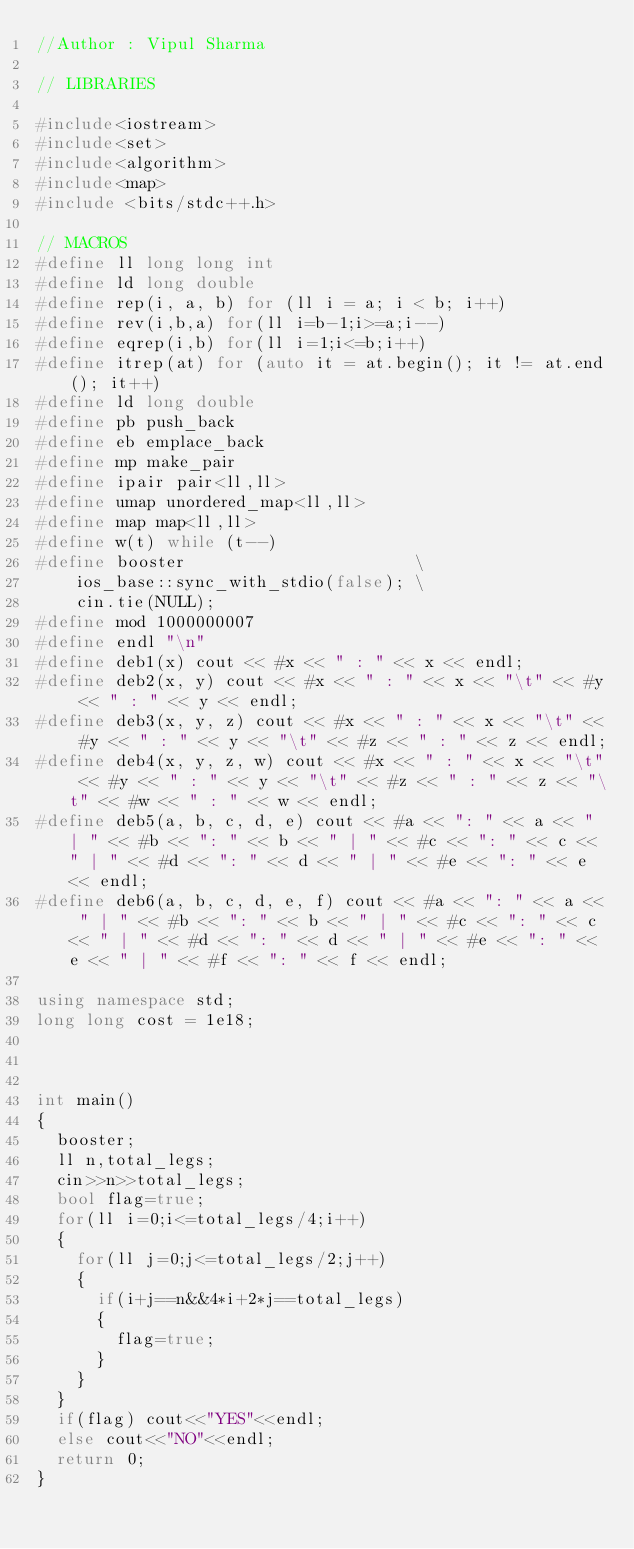Convert code to text. <code><loc_0><loc_0><loc_500><loc_500><_C++_>//Author : Vipul Sharma
 
// LIBRARIES

#include<iostream>
#include<set>
#include<algorithm>
#include<map>
#include <bits/stdc++.h>
 
// MACROS
#define ll long long int
#define ld long double
#define rep(i, a, b) for (ll i = a; i < b; i++)
#define rev(i,b,a) for(ll i=b-1;i>=a;i--)
#define eqrep(i,b) for(ll i=1;i<=b;i++)
#define itrep(at) for (auto it = at.begin(); it != at.end(); it++)
#define ld long double
#define pb push_back
#define eb emplace_back
#define mp make_pair
#define ipair pair<ll,ll>
#define umap unordered_map<ll,ll>
#define map map<ll,ll>
#define w(t) while (t--)
#define booster                       \
    ios_base::sync_with_stdio(false); \
    cin.tie(NULL);
#define mod 1000000007
#define endl "\n"
#define deb1(x) cout << #x << " : " << x << endl;
#define deb2(x, y) cout << #x << " : " << x << "\t" << #y << " : " << y << endl;
#define deb3(x, y, z) cout << #x << " : " << x << "\t" << #y << " : " << y << "\t" << #z << " : " << z << endl;
#define deb4(x, y, z, w) cout << #x << " : " << x << "\t" << #y << " : " << y << "\t" << #z << " : " << z << "\t" << #w << " : " << w << endl;
#define deb5(a, b, c, d, e) cout << #a << ": " << a << " | " << #b << ": " << b << " | " << #c << ": " << c << " | " << #d << ": " << d << " | " << #e << ": " << e << endl;
#define deb6(a, b, c, d, e, f) cout << #a << ": " << a << " | " << #b << ": " << b << " | " << #c << ": " << c << " | " << #d << ": " << d << " | " << #e << ": " << e << " | " << #f << ": " << f << endl;
 
using namespace std;
long long cost = 1e18;
 
 
 
int main()
{
	booster;
	ll n,total_legs;
	cin>>n>>total_legs;
	bool flag=true;
	for(ll i=0;i<=total_legs/4;i++)
	{
		for(ll j=0;j<=total_legs/2;j++)
		{
			if(i+j==n&&4*i+2*j==total_legs)
			{
				flag=true;
			}
		}
	}
	if(flag) cout<<"YES"<<endl;
	else cout<<"NO"<<endl;
	return 0;
}</code> 